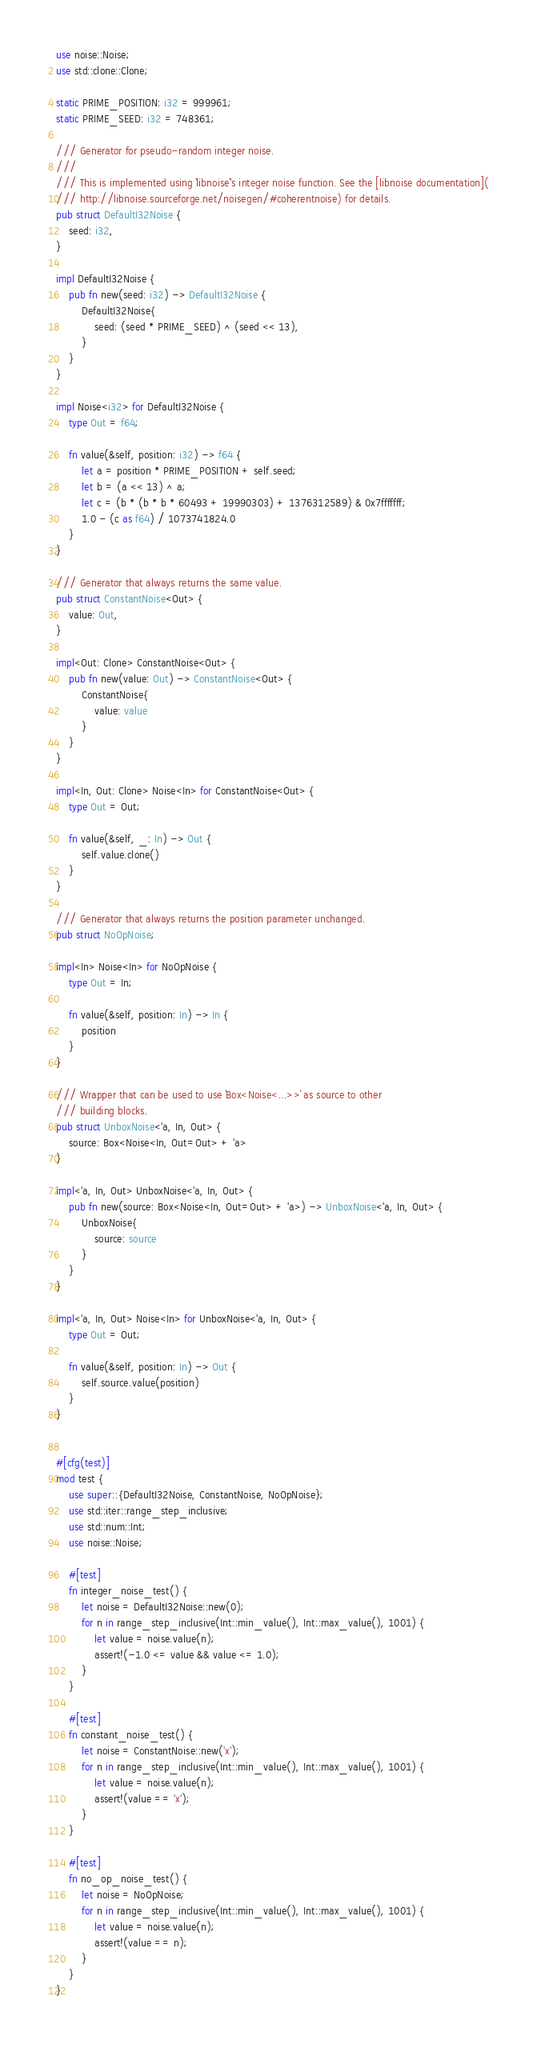Convert code to text. <code><loc_0><loc_0><loc_500><loc_500><_Rust_>use noise::Noise;
use std::clone::Clone;

static PRIME_POSITION: i32 = 999961;
static PRIME_SEED: i32 = 748361;

/// Generator for pseudo-random integer noise.
///
/// This is implemented using `libnoise`'s integer noise function. See the [libnoise documentation](
/// http://libnoise.sourceforge.net/noisegen/#coherentnoise) for details.
pub struct DefaultI32Noise {
    seed: i32,
}

impl DefaultI32Noise {
    pub fn new(seed: i32) -> DefaultI32Noise {
        DefaultI32Noise{
            seed: (seed * PRIME_SEED) ^ (seed << 13),
        }
    }
}

impl Noise<i32> for DefaultI32Noise {
    type Out = f64;

    fn value(&self, position: i32) -> f64 {
        let a = position * PRIME_POSITION + self.seed;
        let b = (a << 13) ^ a;
        let c = (b * (b * b * 60493 + 19990303) + 1376312589) & 0x7fffffff;
        1.0 - (c as f64) / 1073741824.0
    }
}

/// Generator that always returns the same value.
pub struct ConstantNoise<Out> {
    value: Out,
}

impl<Out: Clone> ConstantNoise<Out> {
    pub fn new(value: Out) -> ConstantNoise<Out> {
        ConstantNoise{
            value: value
        }
    }
}

impl<In, Out: Clone> Noise<In> for ConstantNoise<Out> {
    type Out = Out;

    fn value(&self, _: In) -> Out {
        self.value.clone()
    }
}

/// Generator that always returns the position parameter unchanged.
pub struct NoOpNoise;

impl<In> Noise<In> for NoOpNoise {
    type Out = In;

    fn value(&self, position: In) -> In {
        position
    }
}

/// Wrapper that can be used to use `Box<Noise<...>>` as source to other
/// building blocks.
pub struct UnboxNoise<'a, In, Out> {
    source: Box<Noise<In, Out=Out> + 'a>
}

impl<'a, In, Out> UnboxNoise<'a, In, Out> {
    pub fn new(source: Box<Noise<In, Out=Out> + 'a>) -> UnboxNoise<'a, In, Out> {
        UnboxNoise{
            source: source
        }
    }
}

impl<'a, In, Out> Noise<In> for UnboxNoise<'a, In, Out> {
    type Out = Out;

    fn value(&self, position: In) -> Out {
        self.source.value(position)
    }
}


#[cfg(test)]
mod test {
    use super::{DefaultI32Noise, ConstantNoise, NoOpNoise};
    use std::iter::range_step_inclusive;
    use std::num::Int;
    use noise::Noise;

    #[test]
    fn integer_noise_test() {
        let noise = DefaultI32Noise::new(0);
        for n in range_step_inclusive(Int::min_value(), Int::max_value(), 1001) {
            let value = noise.value(n);
            assert!(-1.0 <= value && value <= 1.0);
        }
    }

    #[test]
    fn constant_noise_test() {
        let noise = ConstantNoise::new('x');
        for n in range_step_inclusive(Int::min_value(), Int::max_value(), 1001) {
            let value = noise.value(n);
            assert!(value == 'x');
        }
    }

    #[test]
    fn no_op_noise_test() {
        let noise = NoOpNoise;
        for n in range_step_inclusive(Int::min_value(), Int::max_value(), 1001) {
            let value = noise.value(n);
            assert!(value == n);
        }
    }
}
</code> 